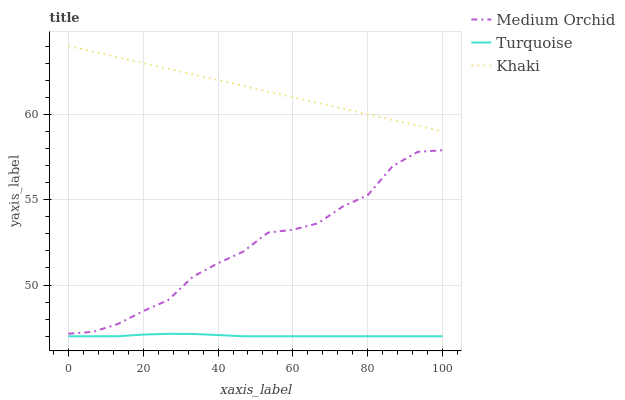Does Turquoise have the minimum area under the curve?
Answer yes or no. Yes. Does Khaki have the maximum area under the curve?
Answer yes or no. Yes. Does Medium Orchid have the minimum area under the curve?
Answer yes or no. No. Does Medium Orchid have the maximum area under the curve?
Answer yes or no. No. Is Khaki the smoothest?
Answer yes or no. Yes. Is Medium Orchid the roughest?
Answer yes or no. Yes. Is Medium Orchid the smoothest?
Answer yes or no. No. Is Khaki the roughest?
Answer yes or no. No. Does Turquoise have the lowest value?
Answer yes or no. Yes. Does Medium Orchid have the lowest value?
Answer yes or no. No. Does Khaki have the highest value?
Answer yes or no. Yes. Does Medium Orchid have the highest value?
Answer yes or no. No. Is Turquoise less than Medium Orchid?
Answer yes or no. Yes. Is Khaki greater than Medium Orchid?
Answer yes or no. Yes. Does Turquoise intersect Medium Orchid?
Answer yes or no. No. 